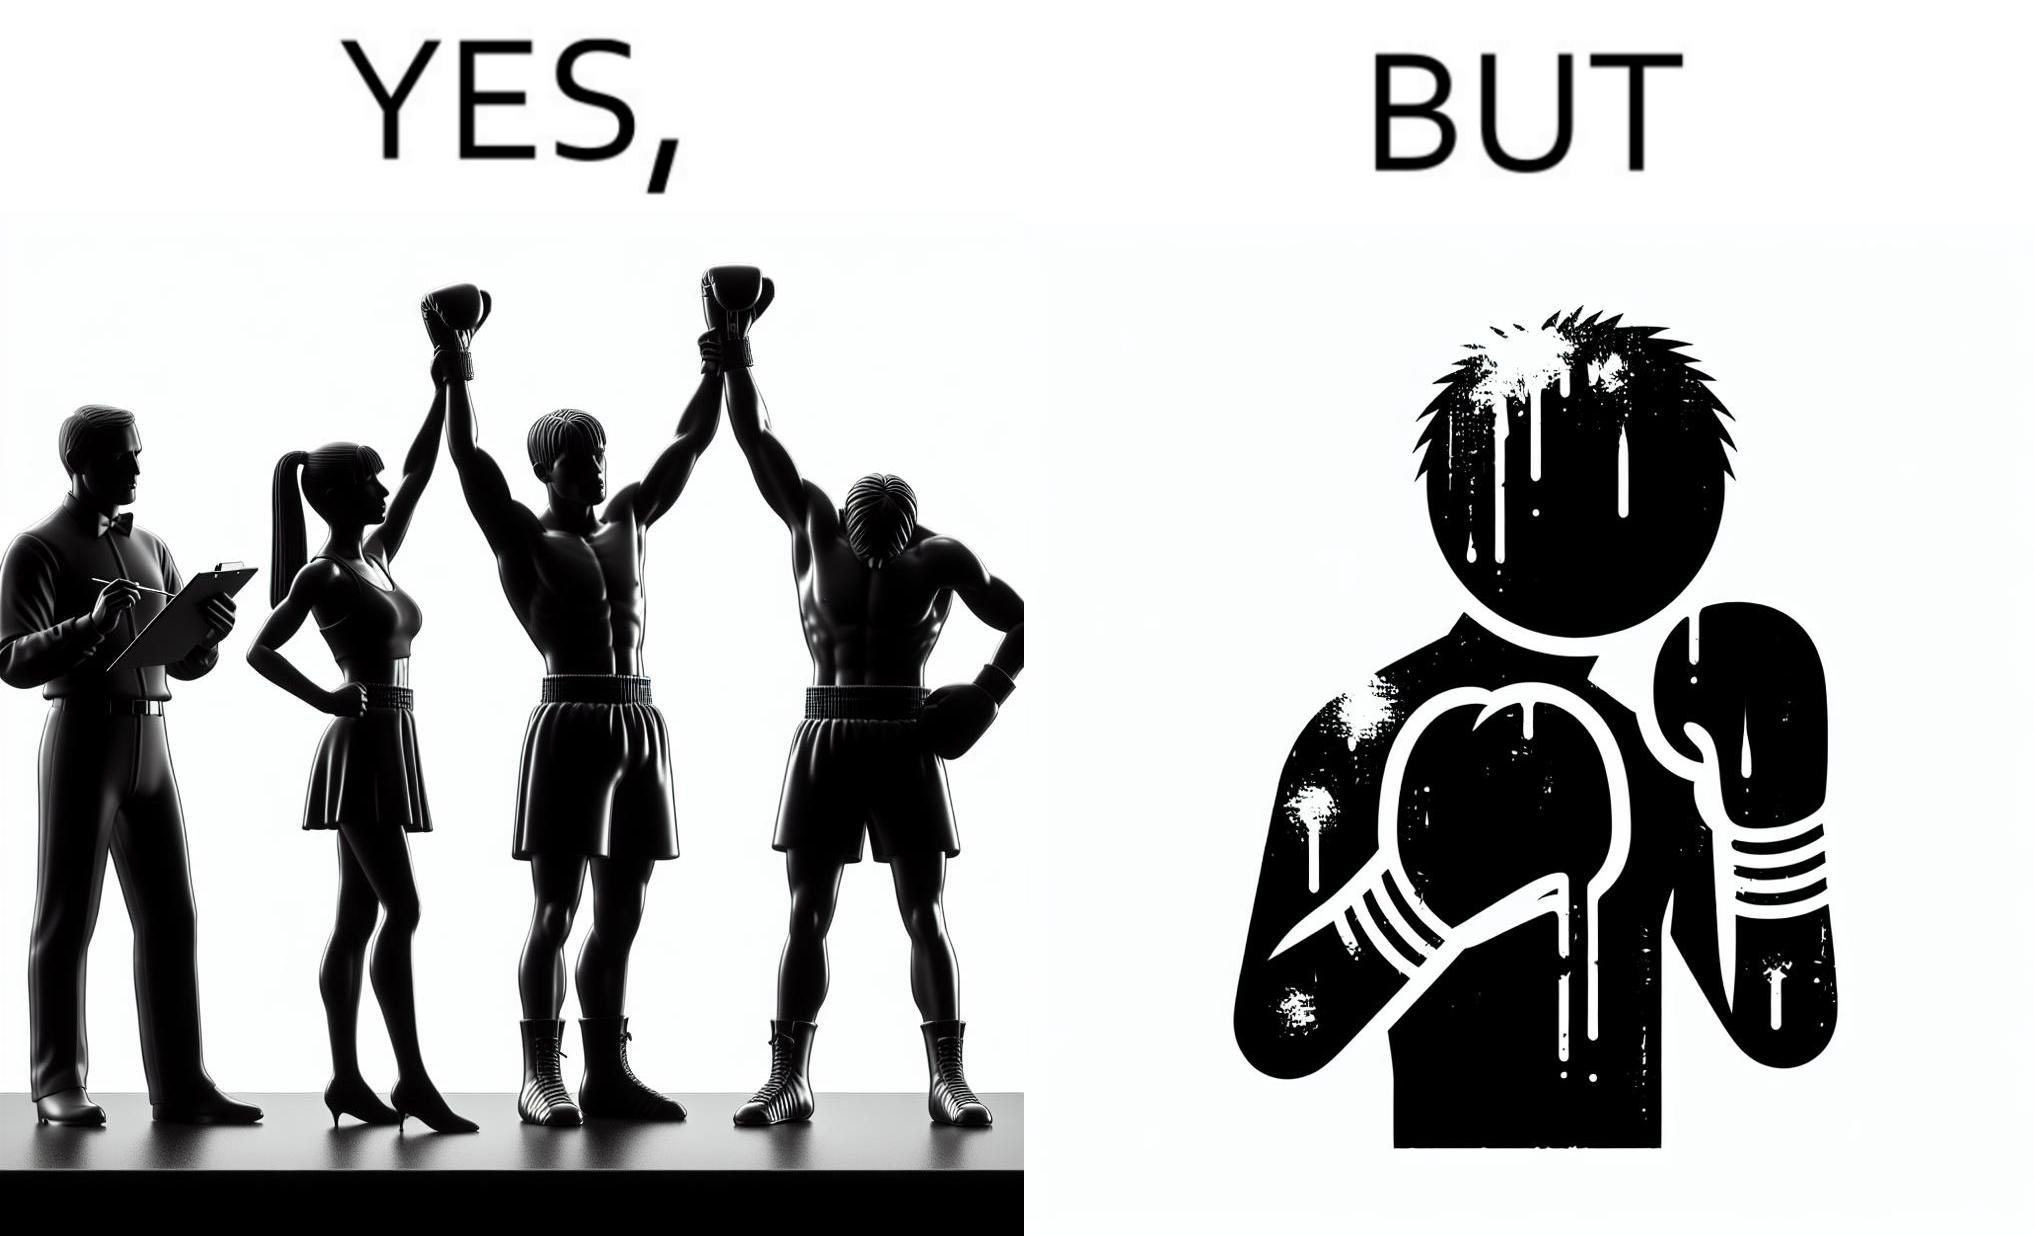Explain the humor or irony in this image. The image is ironic because even though a boxer has won the match and it is supposed to be a moment of celebration, the boxer got bruised in several places during the match. This is an illustration of what hurdles a person has to go through in order to succeed. 